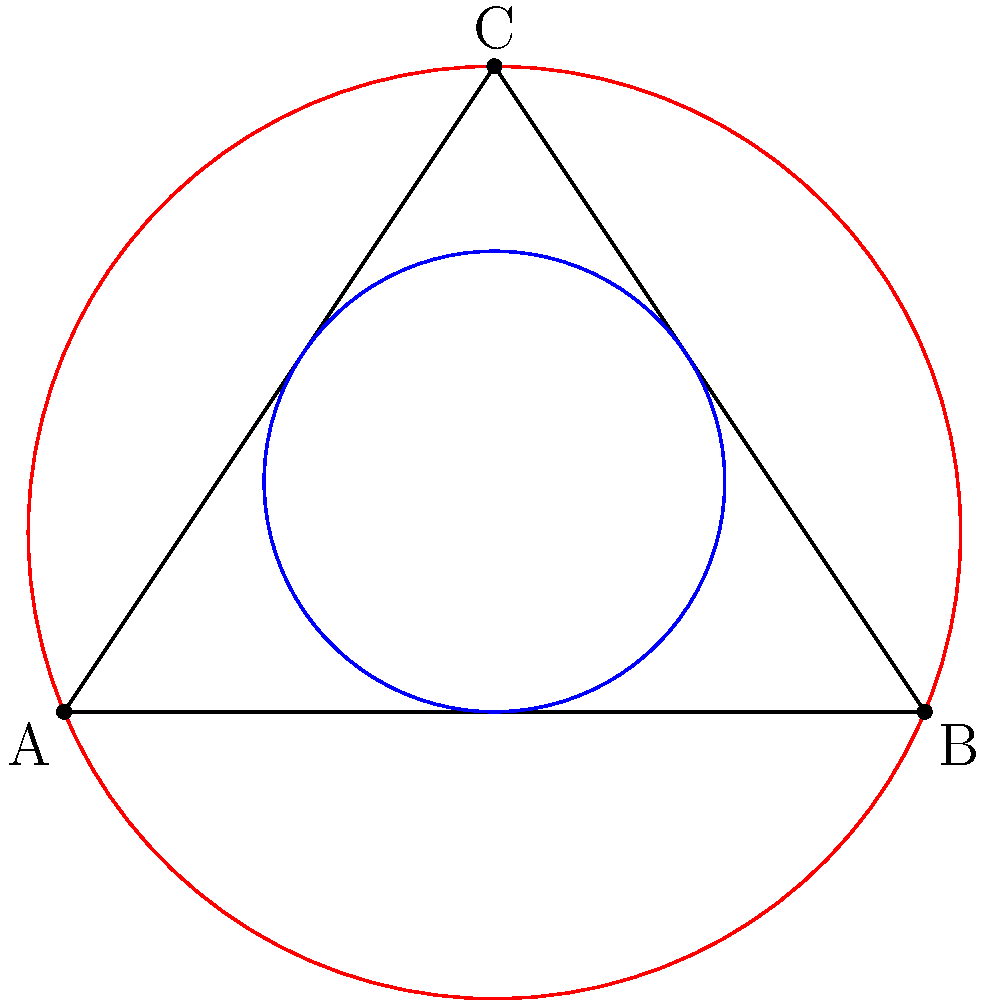In the diagram, a triangle ABC is shown with its inscribed circle (blue) and circumscribed circle (red). If the radius of the inscribed circle is $r$ and the radius of the circumscribed circle is $R$, what is the relationship between $r$, $R$, and the semi-perimeter $s$ of the triangle? Let's approach this step-by-step:

1) First, recall that the semi-perimeter $s$ of a triangle is half its perimeter: $s = \frac{a+b+c}{2}$, where $a$, $b$, and $c$ are the side lengths.

2) For the inscribed circle, we know that its area is given by $A_{in} = rs$, where $r$ is the inradius.

3) For the circumscribed circle, we know that its area is given by $A_{circ} = \frac{abc}{4R}$, where $R$ is the circumradius and $a$, $b$, $c$ are the side lengths.

4) The area of the triangle can also be expressed as $A = \sqrt{s(s-a)(s-b)(s-c)}$ (Heron's formula).

5) Equating the expressions for the triangle's area:

   $rs = \sqrt{s(s-a)(s-b)(s-c)} = \frac{abc}{4R}$

6) Squaring both sides:

   $r^2s^2 = \frac{a^2b^2c^2}{16R^2}$

7) Now, recall the relation $abc = 4Rs$ (which can be derived from other circle theorems).

8) Substituting this into our equation:

   $r^2s^2 = \frac{(4Rs)^2}{16R^2} = s^2$

9) Simplifying:

   $r^2 = 1$

10) Therefore, we can conclude:

    $rR = s$

This elegant relation connects the inradius, circumradius, and semi-perimeter of any triangle.
Answer: $rR = s$ 